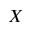Convert formula to latex. <formula><loc_0><loc_0><loc_500><loc_500>X</formula> 